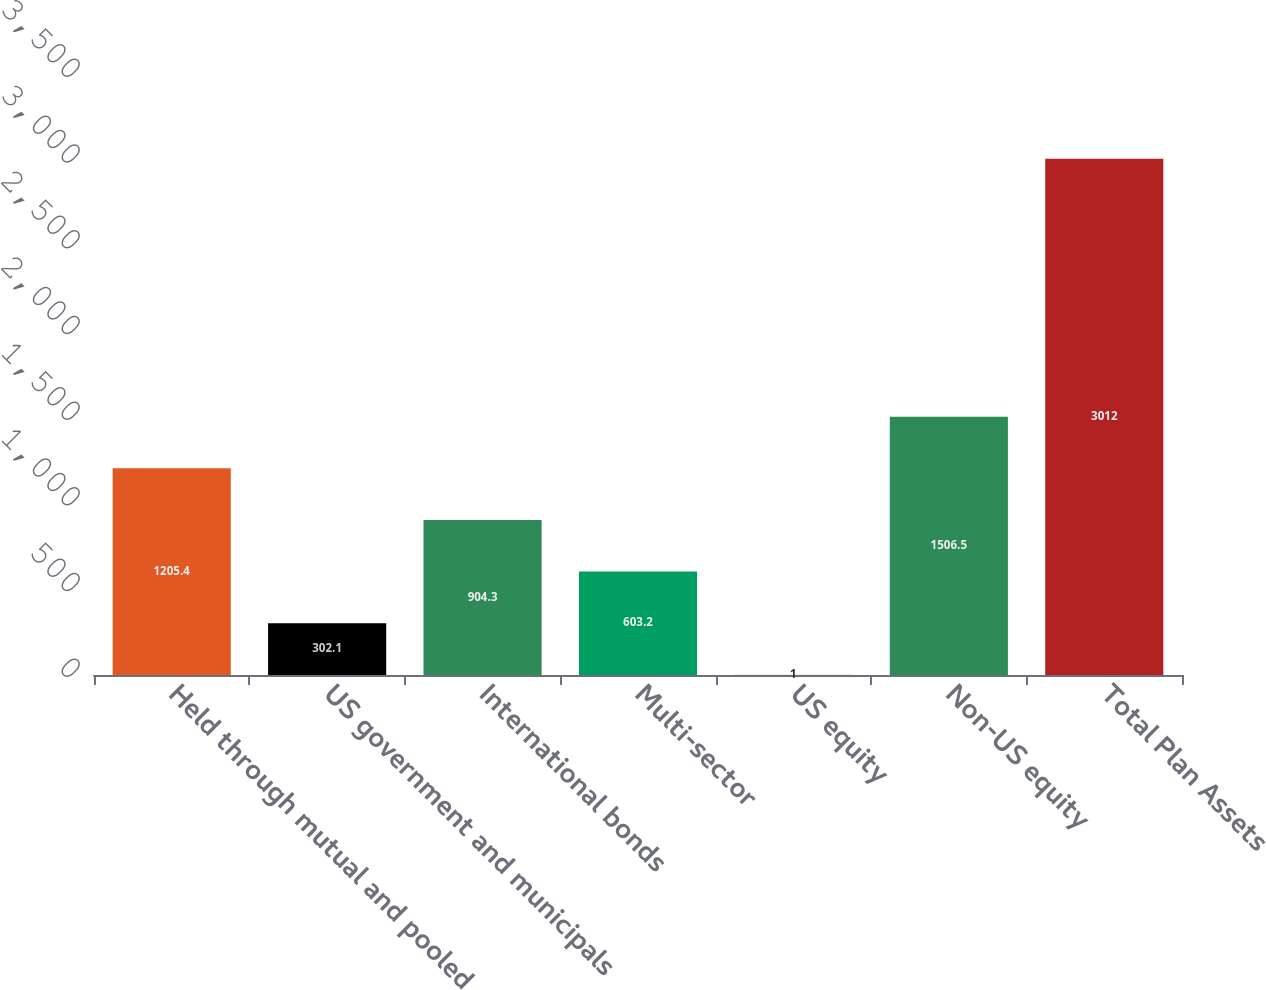Convert chart to OTSL. <chart><loc_0><loc_0><loc_500><loc_500><bar_chart><fcel>Held through mutual and pooled<fcel>US government and municipals<fcel>International bonds<fcel>Multi-sector<fcel>US equity<fcel>Non-US equity<fcel>Total Plan Assets<nl><fcel>1205.4<fcel>302.1<fcel>904.3<fcel>603.2<fcel>1<fcel>1506.5<fcel>3012<nl></chart> 